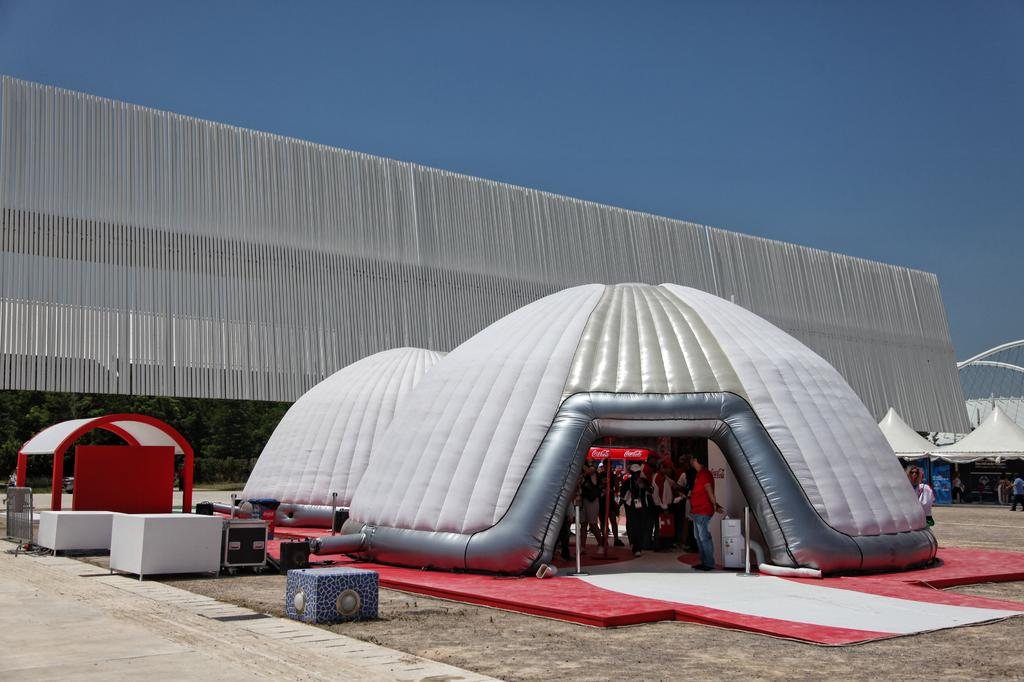What is happening on the ground in the image? There are people on the ground in the image. What type of vegetation can be seen in the image? Plants are visible in the image. What can be seen in the background of the image? The sky is visible in the background of the image. Are there any icicles hanging from the plants in the image? There are no icicles present in the image; it appears to be a warm setting with plants and people on the ground. 